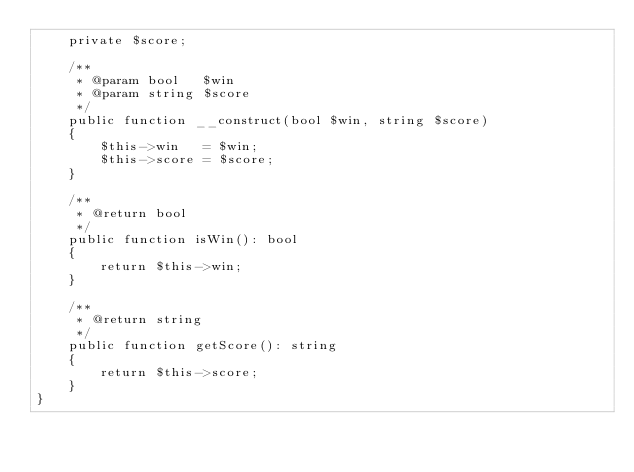Convert code to text. <code><loc_0><loc_0><loc_500><loc_500><_PHP_>    private $score;

    /**
     * @param bool   $win
     * @param string $score
     */
    public function __construct(bool $win, string $score)
    {
        $this->win   = $win;
        $this->score = $score;
    }

    /**
     * @return bool
     */
    public function isWin(): bool
    {
        return $this->win;
    }

    /**
     * @return string
     */
    public function getScore(): string
    {
        return $this->score;
    }
}
</code> 